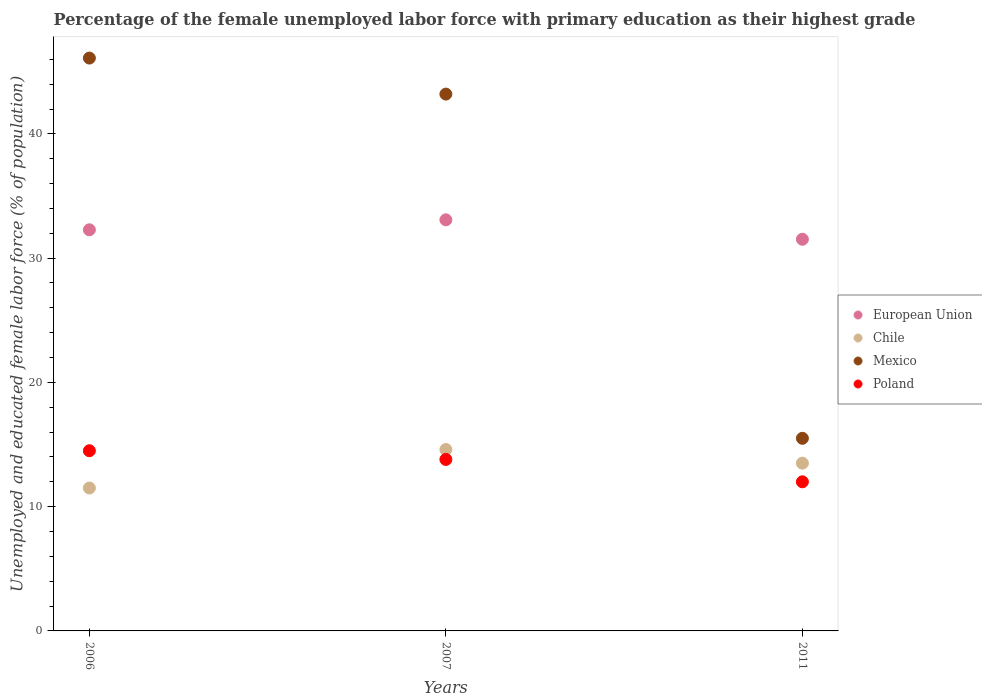How many different coloured dotlines are there?
Make the answer very short. 4. What is the percentage of the unemployed female labor force with primary education in European Union in 2007?
Your answer should be very brief. 33.08. Across all years, what is the maximum percentage of the unemployed female labor force with primary education in Chile?
Offer a terse response. 14.6. Across all years, what is the minimum percentage of the unemployed female labor force with primary education in Poland?
Offer a very short reply. 12. In which year was the percentage of the unemployed female labor force with primary education in European Union maximum?
Your response must be concise. 2007. In which year was the percentage of the unemployed female labor force with primary education in Poland minimum?
Ensure brevity in your answer.  2011. What is the total percentage of the unemployed female labor force with primary education in Mexico in the graph?
Keep it short and to the point. 104.8. What is the difference between the percentage of the unemployed female labor force with primary education in European Union in 2007 and that in 2011?
Offer a very short reply. 1.56. What is the difference between the percentage of the unemployed female labor force with primary education in Poland in 2006 and the percentage of the unemployed female labor force with primary education in Mexico in 2011?
Offer a very short reply. -1. What is the average percentage of the unemployed female labor force with primary education in Mexico per year?
Your response must be concise. 34.93. In the year 2006, what is the difference between the percentage of the unemployed female labor force with primary education in Poland and percentage of the unemployed female labor force with primary education in European Union?
Provide a short and direct response. -17.78. What is the ratio of the percentage of the unemployed female labor force with primary education in Poland in 2006 to that in 2007?
Offer a terse response. 1.05. What is the difference between the highest and the second highest percentage of the unemployed female labor force with primary education in Mexico?
Offer a terse response. 2.9. In how many years, is the percentage of the unemployed female labor force with primary education in Chile greater than the average percentage of the unemployed female labor force with primary education in Chile taken over all years?
Your answer should be very brief. 2. Is the sum of the percentage of the unemployed female labor force with primary education in Chile in 2006 and 2011 greater than the maximum percentage of the unemployed female labor force with primary education in Mexico across all years?
Make the answer very short. No. Is it the case that in every year, the sum of the percentage of the unemployed female labor force with primary education in European Union and percentage of the unemployed female labor force with primary education in Mexico  is greater than the sum of percentage of the unemployed female labor force with primary education in Poland and percentage of the unemployed female labor force with primary education in Chile?
Your answer should be compact. No. Does the percentage of the unemployed female labor force with primary education in Poland monotonically increase over the years?
Keep it short and to the point. No. Is the percentage of the unemployed female labor force with primary education in Poland strictly greater than the percentage of the unemployed female labor force with primary education in Chile over the years?
Give a very brief answer. No. How many dotlines are there?
Provide a short and direct response. 4. How many years are there in the graph?
Offer a very short reply. 3. What is the difference between two consecutive major ticks on the Y-axis?
Your answer should be compact. 10. How are the legend labels stacked?
Give a very brief answer. Vertical. What is the title of the graph?
Your answer should be very brief. Percentage of the female unemployed labor force with primary education as their highest grade. Does "Cuba" appear as one of the legend labels in the graph?
Your answer should be very brief. No. What is the label or title of the Y-axis?
Provide a succinct answer. Unemployed and educated female labor force (% of population). What is the Unemployed and educated female labor force (% of population) in European Union in 2006?
Your answer should be very brief. 32.28. What is the Unemployed and educated female labor force (% of population) of Mexico in 2006?
Make the answer very short. 46.1. What is the Unemployed and educated female labor force (% of population) of Poland in 2006?
Ensure brevity in your answer.  14.5. What is the Unemployed and educated female labor force (% of population) in European Union in 2007?
Your answer should be compact. 33.08. What is the Unemployed and educated female labor force (% of population) of Chile in 2007?
Give a very brief answer. 14.6. What is the Unemployed and educated female labor force (% of population) of Mexico in 2007?
Provide a short and direct response. 43.2. What is the Unemployed and educated female labor force (% of population) of Poland in 2007?
Your answer should be very brief. 13.8. What is the Unemployed and educated female labor force (% of population) in European Union in 2011?
Your answer should be compact. 31.52. What is the Unemployed and educated female labor force (% of population) of Chile in 2011?
Keep it short and to the point. 13.5. What is the Unemployed and educated female labor force (% of population) in Mexico in 2011?
Provide a short and direct response. 15.5. Across all years, what is the maximum Unemployed and educated female labor force (% of population) of European Union?
Give a very brief answer. 33.08. Across all years, what is the maximum Unemployed and educated female labor force (% of population) of Chile?
Provide a short and direct response. 14.6. Across all years, what is the maximum Unemployed and educated female labor force (% of population) in Mexico?
Ensure brevity in your answer.  46.1. Across all years, what is the minimum Unemployed and educated female labor force (% of population) of European Union?
Keep it short and to the point. 31.52. What is the total Unemployed and educated female labor force (% of population) in European Union in the graph?
Your response must be concise. 96.88. What is the total Unemployed and educated female labor force (% of population) in Chile in the graph?
Give a very brief answer. 39.6. What is the total Unemployed and educated female labor force (% of population) of Mexico in the graph?
Give a very brief answer. 104.8. What is the total Unemployed and educated female labor force (% of population) in Poland in the graph?
Ensure brevity in your answer.  40.3. What is the difference between the Unemployed and educated female labor force (% of population) in European Union in 2006 and that in 2007?
Your answer should be very brief. -0.8. What is the difference between the Unemployed and educated female labor force (% of population) in Poland in 2006 and that in 2007?
Give a very brief answer. 0.7. What is the difference between the Unemployed and educated female labor force (% of population) in European Union in 2006 and that in 2011?
Give a very brief answer. 0.76. What is the difference between the Unemployed and educated female labor force (% of population) of Chile in 2006 and that in 2011?
Give a very brief answer. -2. What is the difference between the Unemployed and educated female labor force (% of population) of Mexico in 2006 and that in 2011?
Provide a succinct answer. 30.6. What is the difference between the Unemployed and educated female labor force (% of population) of Poland in 2006 and that in 2011?
Make the answer very short. 2.5. What is the difference between the Unemployed and educated female labor force (% of population) of European Union in 2007 and that in 2011?
Keep it short and to the point. 1.56. What is the difference between the Unemployed and educated female labor force (% of population) of Chile in 2007 and that in 2011?
Offer a terse response. 1.1. What is the difference between the Unemployed and educated female labor force (% of population) in Mexico in 2007 and that in 2011?
Your answer should be compact. 27.7. What is the difference between the Unemployed and educated female labor force (% of population) of Poland in 2007 and that in 2011?
Ensure brevity in your answer.  1.8. What is the difference between the Unemployed and educated female labor force (% of population) in European Union in 2006 and the Unemployed and educated female labor force (% of population) in Chile in 2007?
Offer a terse response. 17.68. What is the difference between the Unemployed and educated female labor force (% of population) in European Union in 2006 and the Unemployed and educated female labor force (% of population) in Mexico in 2007?
Ensure brevity in your answer.  -10.92. What is the difference between the Unemployed and educated female labor force (% of population) in European Union in 2006 and the Unemployed and educated female labor force (% of population) in Poland in 2007?
Offer a terse response. 18.48. What is the difference between the Unemployed and educated female labor force (% of population) in Chile in 2006 and the Unemployed and educated female labor force (% of population) in Mexico in 2007?
Your response must be concise. -31.7. What is the difference between the Unemployed and educated female labor force (% of population) of Mexico in 2006 and the Unemployed and educated female labor force (% of population) of Poland in 2007?
Offer a very short reply. 32.3. What is the difference between the Unemployed and educated female labor force (% of population) in European Union in 2006 and the Unemployed and educated female labor force (% of population) in Chile in 2011?
Ensure brevity in your answer.  18.78. What is the difference between the Unemployed and educated female labor force (% of population) of European Union in 2006 and the Unemployed and educated female labor force (% of population) of Mexico in 2011?
Provide a short and direct response. 16.78. What is the difference between the Unemployed and educated female labor force (% of population) in European Union in 2006 and the Unemployed and educated female labor force (% of population) in Poland in 2011?
Ensure brevity in your answer.  20.28. What is the difference between the Unemployed and educated female labor force (% of population) in Mexico in 2006 and the Unemployed and educated female labor force (% of population) in Poland in 2011?
Make the answer very short. 34.1. What is the difference between the Unemployed and educated female labor force (% of population) of European Union in 2007 and the Unemployed and educated female labor force (% of population) of Chile in 2011?
Ensure brevity in your answer.  19.58. What is the difference between the Unemployed and educated female labor force (% of population) in European Union in 2007 and the Unemployed and educated female labor force (% of population) in Mexico in 2011?
Your response must be concise. 17.58. What is the difference between the Unemployed and educated female labor force (% of population) of European Union in 2007 and the Unemployed and educated female labor force (% of population) of Poland in 2011?
Provide a succinct answer. 21.08. What is the difference between the Unemployed and educated female labor force (% of population) in Mexico in 2007 and the Unemployed and educated female labor force (% of population) in Poland in 2011?
Ensure brevity in your answer.  31.2. What is the average Unemployed and educated female labor force (% of population) of European Union per year?
Give a very brief answer. 32.29. What is the average Unemployed and educated female labor force (% of population) in Chile per year?
Give a very brief answer. 13.2. What is the average Unemployed and educated female labor force (% of population) in Mexico per year?
Provide a short and direct response. 34.93. What is the average Unemployed and educated female labor force (% of population) in Poland per year?
Your answer should be very brief. 13.43. In the year 2006, what is the difference between the Unemployed and educated female labor force (% of population) in European Union and Unemployed and educated female labor force (% of population) in Chile?
Give a very brief answer. 20.78. In the year 2006, what is the difference between the Unemployed and educated female labor force (% of population) of European Union and Unemployed and educated female labor force (% of population) of Mexico?
Provide a succinct answer. -13.82. In the year 2006, what is the difference between the Unemployed and educated female labor force (% of population) of European Union and Unemployed and educated female labor force (% of population) of Poland?
Your response must be concise. 17.78. In the year 2006, what is the difference between the Unemployed and educated female labor force (% of population) in Chile and Unemployed and educated female labor force (% of population) in Mexico?
Make the answer very short. -34.6. In the year 2006, what is the difference between the Unemployed and educated female labor force (% of population) of Chile and Unemployed and educated female labor force (% of population) of Poland?
Your answer should be very brief. -3. In the year 2006, what is the difference between the Unemployed and educated female labor force (% of population) in Mexico and Unemployed and educated female labor force (% of population) in Poland?
Keep it short and to the point. 31.6. In the year 2007, what is the difference between the Unemployed and educated female labor force (% of population) in European Union and Unemployed and educated female labor force (% of population) in Chile?
Ensure brevity in your answer.  18.48. In the year 2007, what is the difference between the Unemployed and educated female labor force (% of population) in European Union and Unemployed and educated female labor force (% of population) in Mexico?
Provide a short and direct response. -10.12. In the year 2007, what is the difference between the Unemployed and educated female labor force (% of population) of European Union and Unemployed and educated female labor force (% of population) of Poland?
Your answer should be compact. 19.28. In the year 2007, what is the difference between the Unemployed and educated female labor force (% of population) in Chile and Unemployed and educated female labor force (% of population) in Mexico?
Offer a very short reply. -28.6. In the year 2007, what is the difference between the Unemployed and educated female labor force (% of population) in Mexico and Unemployed and educated female labor force (% of population) in Poland?
Your answer should be compact. 29.4. In the year 2011, what is the difference between the Unemployed and educated female labor force (% of population) of European Union and Unemployed and educated female labor force (% of population) of Chile?
Provide a succinct answer. 18.02. In the year 2011, what is the difference between the Unemployed and educated female labor force (% of population) of European Union and Unemployed and educated female labor force (% of population) of Mexico?
Keep it short and to the point. 16.02. In the year 2011, what is the difference between the Unemployed and educated female labor force (% of population) of European Union and Unemployed and educated female labor force (% of population) of Poland?
Keep it short and to the point. 19.52. In the year 2011, what is the difference between the Unemployed and educated female labor force (% of population) of Chile and Unemployed and educated female labor force (% of population) of Mexico?
Ensure brevity in your answer.  -2. In the year 2011, what is the difference between the Unemployed and educated female labor force (% of population) in Chile and Unemployed and educated female labor force (% of population) in Poland?
Your response must be concise. 1.5. What is the ratio of the Unemployed and educated female labor force (% of population) of European Union in 2006 to that in 2007?
Offer a very short reply. 0.98. What is the ratio of the Unemployed and educated female labor force (% of population) in Chile in 2006 to that in 2007?
Make the answer very short. 0.79. What is the ratio of the Unemployed and educated female labor force (% of population) in Mexico in 2006 to that in 2007?
Give a very brief answer. 1.07. What is the ratio of the Unemployed and educated female labor force (% of population) of Poland in 2006 to that in 2007?
Offer a terse response. 1.05. What is the ratio of the Unemployed and educated female labor force (% of population) of European Union in 2006 to that in 2011?
Ensure brevity in your answer.  1.02. What is the ratio of the Unemployed and educated female labor force (% of population) in Chile in 2006 to that in 2011?
Provide a succinct answer. 0.85. What is the ratio of the Unemployed and educated female labor force (% of population) of Mexico in 2006 to that in 2011?
Your answer should be very brief. 2.97. What is the ratio of the Unemployed and educated female labor force (% of population) of Poland in 2006 to that in 2011?
Your answer should be compact. 1.21. What is the ratio of the Unemployed and educated female labor force (% of population) of European Union in 2007 to that in 2011?
Make the answer very short. 1.05. What is the ratio of the Unemployed and educated female labor force (% of population) in Chile in 2007 to that in 2011?
Provide a succinct answer. 1.08. What is the ratio of the Unemployed and educated female labor force (% of population) of Mexico in 2007 to that in 2011?
Keep it short and to the point. 2.79. What is the ratio of the Unemployed and educated female labor force (% of population) in Poland in 2007 to that in 2011?
Your response must be concise. 1.15. What is the difference between the highest and the second highest Unemployed and educated female labor force (% of population) of European Union?
Your response must be concise. 0.8. What is the difference between the highest and the second highest Unemployed and educated female labor force (% of population) in Mexico?
Your response must be concise. 2.9. What is the difference between the highest and the lowest Unemployed and educated female labor force (% of population) in European Union?
Ensure brevity in your answer.  1.56. What is the difference between the highest and the lowest Unemployed and educated female labor force (% of population) in Mexico?
Offer a very short reply. 30.6. What is the difference between the highest and the lowest Unemployed and educated female labor force (% of population) of Poland?
Your answer should be very brief. 2.5. 